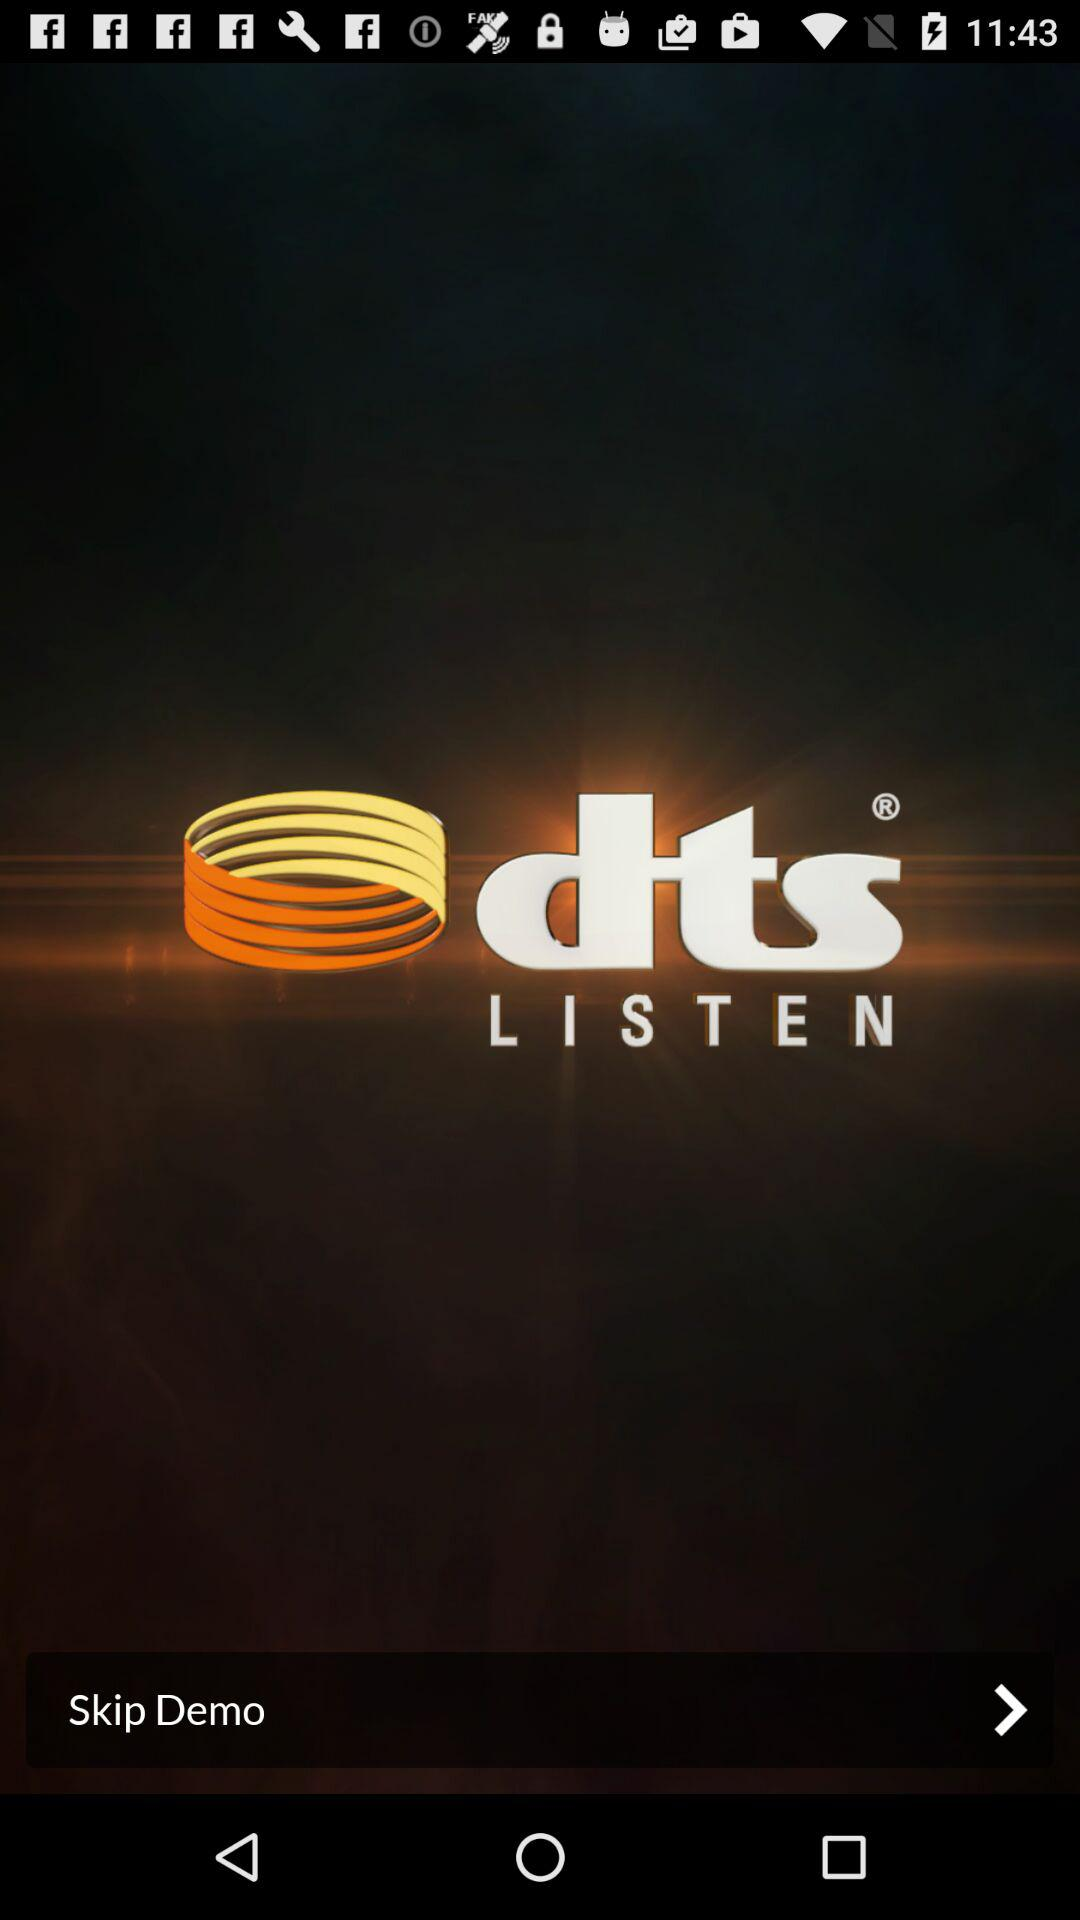What is the version number?
When the provided information is insufficient, respond with <no answer>. <no answer> 